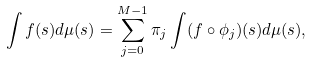Convert formula to latex. <formula><loc_0><loc_0><loc_500><loc_500>\int f ( s ) d \mu ( s ) = \sum _ { j = 0 } ^ { M - 1 } \pi _ { j } \int ( f \circ \phi _ { j } ) ( s ) d \mu ( s ) ,</formula> 